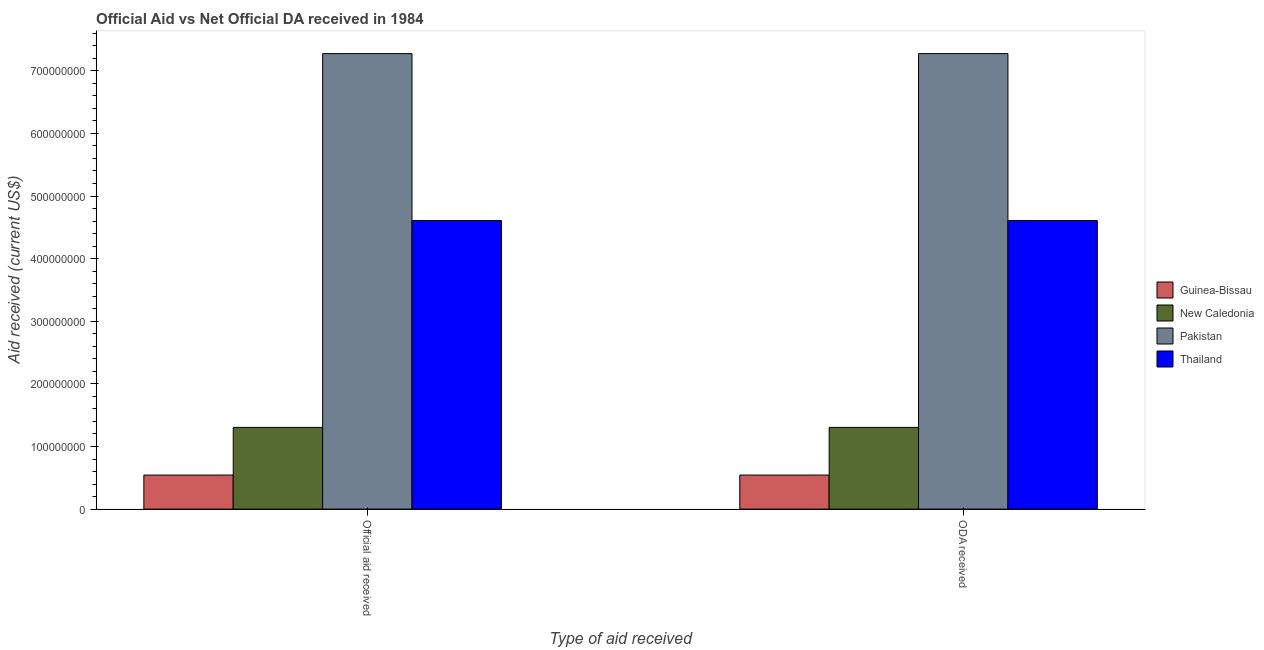How many different coloured bars are there?
Make the answer very short. 4. How many groups of bars are there?
Give a very brief answer. 2. Are the number of bars per tick equal to the number of legend labels?
Offer a terse response. Yes. How many bars are there on the 2nd tick from the left?
Your response must be concise. 4. How many bars are there on the 1st tick from the right?
Offer a very short reply. 4. What is the label of the 2nd group of bars from the left?
Your answer should be very brief. ODA received. What is the official aid received in New Caledonia?
Make the answer very short. 1.31e+08. Across all countries, what is the maximum official aid received?
Make the answer very short. 7.27e+08. Across all countries, what is the minimum official aid received?
Ensure brevity in your answer.  5.44e+07. In which country was the oda received minimum?
Provide a succinct answer. Guinea-Bissau. What is the total official aid received in the graph?
Offer a terse response. 1.37e+09. What is the difference between the official aid received in Pakistan and that in New Caledonia?
Give a very brief answer. 5.97e+08. What is the difference between the official aid received in Guinea-Bissau and the oda received in Pakistan?
Your answer should be compact. -6.73e+08. What is the average oda received per country?
Keep it short and to the point. 3.43e+08. In how many countries, is the official aid received greater than 40000000 US$?
Make the answer very short. 4. What is the ratio of the oda received in Guinea-Bissau to that in Pakistan?
Provide a short and direct response. 0.07. Is the oda received in Pakistan less than that in Thailand?
Your answer should be compact. No. In how many countries, is the official aid received greater than the average official aid received taken over all countries?
Your response must be concise. 2. What does the 1st bar from the left in ODA received represents?
Offer a terse response. Guinea-Bissau. What does the 1st bar from the right in ODA received represents?
Offer a terse response. Thailand. How many countries are there in the graph?
Offer a very short reply. 4. Where does the legend appear in the graph?
Provide a succinct answer. Center right. How are the legend labels stacked?
Provide a short and direct response. Vertical. What is the title of the graph?
Your answer should be very brief. Official Aid vs Net Official DA received in 1984 . Does "Tajikistan" appear as one of the legend labels in the graph?
Your answer should be compact. No. What is the label or title of the X-axis?
Provide a succinct answer. Type of aid received. What is the label or title of the Y-axis?
Offer a terse response. Aid received (current US$). What is the Aid received (current US$) of Guinea-Bissau in Official aid received?
Your response must be concise. 5.44e+07. What is the Aid received (current US$) in New Caledonia in Official aid received?
Offer a terse response. 1.31e+08. What is the Aid received (current US$) in Pakistan in Official aid received?
Your answer should be compact. 7.27e+08. What is the Aid received (current US$) in Thailand in Official aid received?
Provide a short and direct response. 4.61e+08. What is the Aid received (current US$) of Guinea-Bissau in ODA received?
Keep it short and to the point. 5.44e+07. What is the Aid received (current US$) of New Caledonia in ODA received?
Offer a terse response. 1.31e+08. What is the Aid received (current US$) in Pakistan in ODA received?
Ensure brevity in your answer.  7.27e+08. What is the Aid received (current US$) of Thailand in ODA received?
Make the answer very short. 4.61e+08. Across all Type of aid received, what is the maximum Aid received (current US$) in Guinea-Bissau?
Keep it short and to the point. 5.44e+07. Across all Type of aid received, what is the maximum Aid received (current US$) in New Caledonia?
Offer a very short reply. 1.31e+08. Across all Type of aid received, what is the maximum Aid received (current US$) of Pakistan?
Your answer should be compact. 7.27e+08. Across all Type of aid received, what is the maximum Aid received (current US$) in Thailand?
Provide a succinct answer. 4.61e+08. Across all Type of aid received, what is the minimum Aid received (current US$) of Guinea-Bissau?
Provide a succinct answer. 5.44e+07. Across all Type of aid received, what is the minimum Aid received (current US$) in New Caledonia?
Keep it short and to the point. 1.31e+08. Across all Type of aid received, what is the minimum Aid received (current US$) in Pakistan?
Offer a very short reply. 7.27e+08. Across all Type of aid received, what is the minimum Aid received (current US$) of Thailand?
Offer a terse response. 4.61e+08. What is the total Aid received (current US$) in Guinea-Bissau in the graph?
Keep it short and to the point. 1.09e+08. What is the total Aid received (current US$) of New Caledonia in the graph?
Make the answer very short. 2.61e+08. What is the total Aid received (current US$) of Pakistan in the graph?
Provide a succinct answer. 1.45e+09. What is the total Aid received (current US$) of Thailand in the graph?
Give a very brief answer. 9.22e+08. What is the difference between the Aid received (current US$) of Pakistan in Official aid received and that in ODA received?
Ensure brevity in your answer.  0. What is the difference between the Aid received (current US$) of Thailand in Official aid received and that in ODA received?
Keep it short and to the point. 0. What is the difference between the Aid received (current US$) of Guinea-Bissau in Official aid received and the Aid received (current US$) of New Caledonia in ODA received?
Your response must be concise. -7.61e+07. What is the difference between the Aid received (current US$) in Guinea-Bissau in Official aid received and the Aid received (current US$) in Pakistan in ODA received?
Your answer should be very brief. -6.73e+08. What is the difference between the Aid received (current US$) of Guinea-Bissau in Official aid received and the Aid received (current US$) of Thailand in ODA received?
Offer a terse response. -4.07e+08. What is the difference between the Aid received (current US$) in New Caledonia in Official aid received and the Aid received (current US$) in Pakistan in ODA received?
Provide a succinct answer. -5.97e+08. What is the difference between the Aid received (current US$) of New Caledonia in Official aid received and the Aid received (current US$) of Thailand in ODA received?
Provide a succinct answer. -3.30e+08. What is the difference between the Aid received (current US$) of Pakistan in Official aid received and the Aid received (current US$) of Thailand in ODA received?
Offer a very short reply. 2.67e+08. What is the average Aid received (current US$) of Guinea-Bissau per Type of aid received?
Your answer should be very brief. 5.44e+07. What is the average Aid received (current US$) in New Caledonia per Type of aid received?
Your answer should be very brief. 1.31e+08. What is the average Aid received (current US$) in Pakistan per Type of aid received?
Your answer should be very brief. 7.27e+08. What is the average Aid received (current US$) of Thailand per Type of aid received?
Your response must be concise. 4.61e+08. What is the difference between the Aid received (current US$) of Guinea-Bissau and Aid received (current US$) of New Caledonia in Official aid received?
Your response must be concise. -7.61e+07. What is the difference between the Aid received (current US$) of Guinea-Bissau and Aid received (current US$) of Pakistan in Official aid received?
Ensure brevity in your answer.  -6.73e+08. What is the difference between the Aid received (current US$) in Guinea-Bissau and Aid received (current US$) in Thailand in Official aid received?
Keep it short and to the point. -4.07e+08. What is the difference between the Aid received (current US$) in New Caledonia and Aid received (current US$) in Pakistan in Official aid received?
Provide a succinct answer. -5.97e+08. What is the difference between the Aid received (current US$) of New Caledonia and Aid received (current US$) of Thailand in Official aid received?
Provide a short and direct response. -3.30e+08. What is the difference between the Aid received (current US$) in Pakistan and Aid received (current US$) in Thailand in Official aid received?
Ensure brevity in your answer.  2.67e+08. What is the difference between the Aid received (current US$) in Guinea-Bissau and Aid received (current US$) in New Caledonia in ODA received?
Keep it short and to the point. -7.61e+07. What is the difference between the Aid received (current US$) in Guinea-Bissau and Aid received (current US$) in Pakistan in ODA received?
Keep it short and to the point. -6.73e+08. What is the difference between the Aid received (current US$) of Guinea-Bissau and Aid received (current US$) of Thailand in ODA received?
Make the answer very short. -4.07e+08. What is the difference between the Aid received (current US$) of New Caledonia and Aid received (current US$) of Pakistan in ODA received?
Offer a very short reply. -5.97e+08. What is the difference between the Aid received (current US$) of New Caledonia and Aid received (current US$) of Thailand in ODA received?
Your response must be concise. -3.30e+08. What is the difference between the Aid received (current US$) in Pakistan and Aid received (current US$) in Thailand in ODA received?
Give a very brief answer. 2.67e+08. What is the ratio of the Aid received (current US$) of Guinea-Bissau in Official aid received to that in ODA received?
Provide a succinct answer. 1. What is the ratio of the Aid received (current US$) in New Caledonia in Official aid received to that in ODA received?
Keep it short and to the point. 1. What is the ratio of the Aid received (current US$) of Thailand in Official aid received to that in ODA received?
Your response must be concise. 1. What is the difference between the highest and the second highest Aid received (current US$) of Guinea-Bissau?
Your answer should be very brief. 0. What is the difference between the highest and the lowest Aid received (current US$) in Guinea-Bissau?
Your answer should be compact. 0. What is the difference between the highest and the lowest Aid received (current US$) in New Caledonia?
Offer a terse response. 0. What is the difference between the highest and the lowest Aid received (current US$) in Pakistan?
Offer a terse response. 0. 